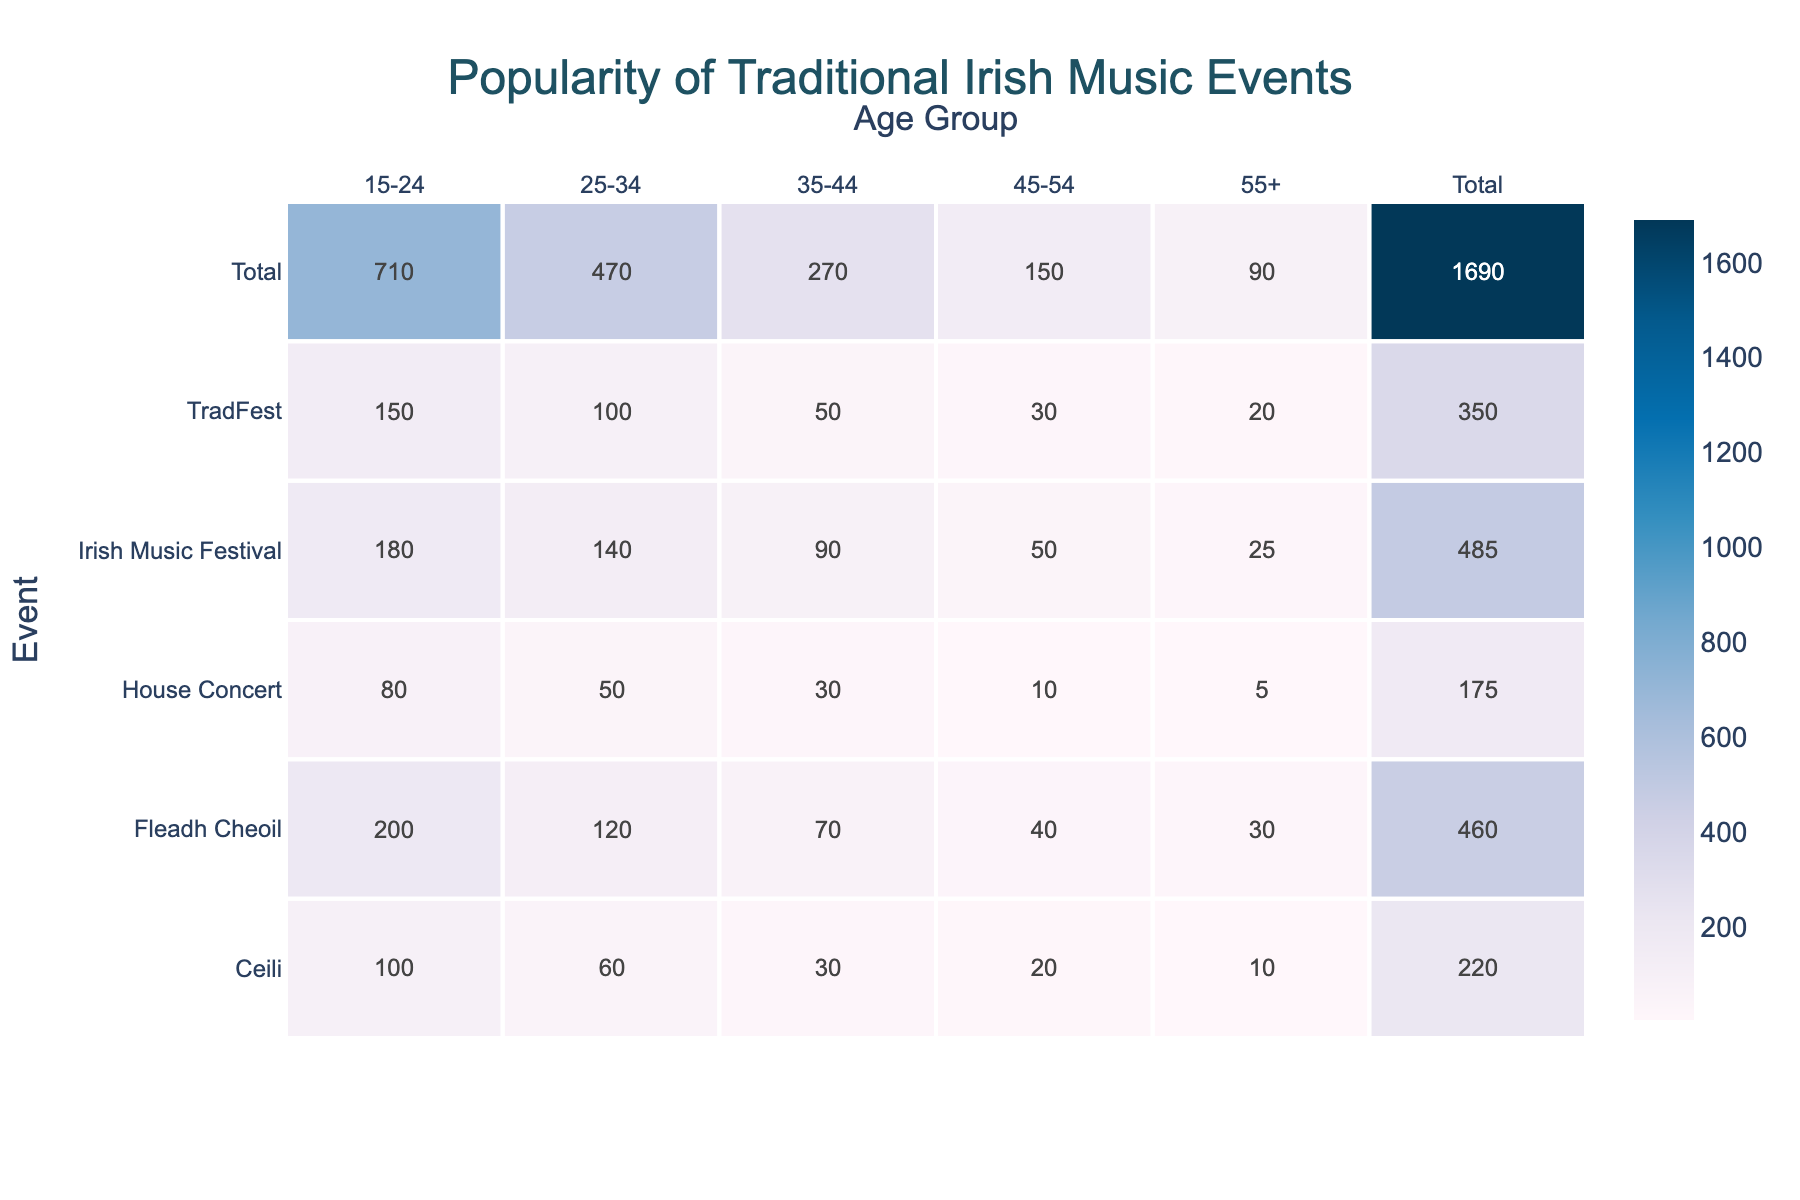What is the total attendance for the Fleadh Cheoil event? To find the total attendance for the Fleadh Cheoil event, I need to sum the attendance across all age groups. The attendance values are: 200 (15-24) + 120 (25-34) + 70 (35-44) + 40 (45-54) + 30 (55+) = 560.
Answer: 560 Which age group has the highest attendance at the Irish Music Festival? By looking at the attendance numbers for the Irish Music Festival, the values are: 180 (15-24), 140 (25-34), 90 (35-44), 50 (45-54), and 25 (55+). The highest value is 180 for the 15-24 age group.
Answer: 15-24 What is the average attendance of all events for the age group 45-54? First, I need to find the attendance for the 45-54 age group across all events: 30 (TradFest) + 40 (Fleadh Cheoil) + 50 (Irish Music Festival) + 20 (Ceili) + 10 (House Concert) = 150. There are 5 events, so the average is 150/5 = 30.
Answer: 30 Is the attendance for House Concert in the 25-34 age group higher than that for the Ceili in the same age group? The attendance for House Concert in the 25-34 age group is 50, while for Ceili, it is 60. Since 50 is less than 60, the statement is false.
Answer: No What is the difference in attendance between the youngest and oldest age groups for the TradFest? The attendance for the youngest age group (15-24) is 150, and for the oldest age group (55+), it is 20. To find the difference, subtract 20 from 150: 150 - 20 = 130.
Answer: 130 Which two events have the lowest total attendance across all age groups? I need to calculate the total attendance for each event: TradFest = 350, Fleadh Cheoil = 560, Irish Music Festival = 485, Ceili = 220, and House Concert = 175. The two lowest totals are Ceili (220) and House Concert (175).
Answer: Ceili and House Concert What percentage of the total attendance for the Irish Music Festival comes from the 15-24 age group? The attendance for the 15-24 age group is 180, and the total attendance for the Irish Music Festival is 485. To find the percentage, divide 180 by 485 and multiply by 100: (180/485) * 100 ≈ 37.11%.
Answer: 37.11% Does the average attendance of the 55+ age group across all events exceed 20? The attendances for the 55+ age group are: 20 (TradFest), 30 (Fleadh Cheoil), 25 (Irish Music Festival), 10 (Ceili), and 5 (House Concert). Their sum is 90, and the average is 90/5 = 18. Since 18 is less than 20, the statement is false.
Answer: No 